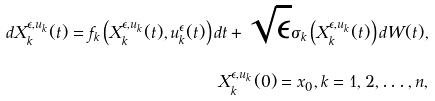<formula> <loc_0><loc_0><loc_500><loc_500>d X _ { k } ^ { \epsilon , u _ { k } } ( t ) = f _ { k } \left ( X _ { k } ^ { \epsilon , u _ { k } } ( t ) , u _ { k } ^ { \epsilon } ( t ) \right ) d t + \sqrt { \epsilon } \sigma _ { k } \left ( X _ { k } ^ { \epsilon , u _ { k } } ( t ) \right ) d W ( t ) , \\ X _ { k } ^ { \epsilon , u _ { k } } ( 0 ) = x _ { 0 } , k = 1 , 2 , \dots , n ,</formula> 